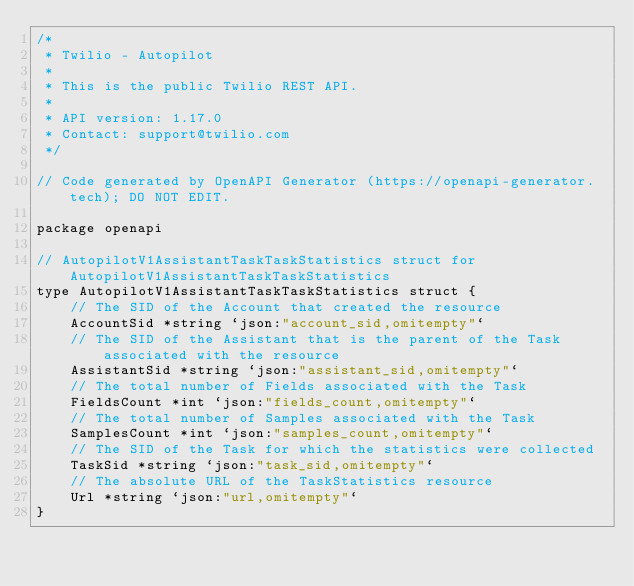<code> <loc_0><loc_0><loc_500><loc_500><_Go_>/*
 * Twilio - Autopilot
 *
 * This is the public Twilio REST API.
 *
 * API version: 1.17.0
 * Contact: support@twilio.com
 */

// Code generated by OpenAPI Generator (https://openapi-generator.tech); DO NOT EDIT.

package openapi

// AutopilotV1AssistantTaskTaskStatistics struct for AutopilotV1AssistantTaskTaskStatistics
type AutopilotV1AssistantTaskTaskStatistics struct {
	// The SID of the Account that created the resource
	AccountSid *string `json:"account_sid,omitempty"`
	// The SID of the Assistant that is the parent of the Task associated with the resource
	AssistantSid *string `json:"assistant_sid,omitempty"`
	// The total number of Fields associated with the Task
	FieldsCount *int `json:"fields_count,omitempty"`
	// The total number of Samples associated with the Task
	SamplesCount *int `json:"samples_count,omitempty"`
	// The SID of the Task for which the statistics were collected
	TaskSid *string `json:"task_sid,omitempty"`
	// The absolute URL of the TaskStatistics resource
	Url *string `json:"url,omitempty"`
}
</code> 